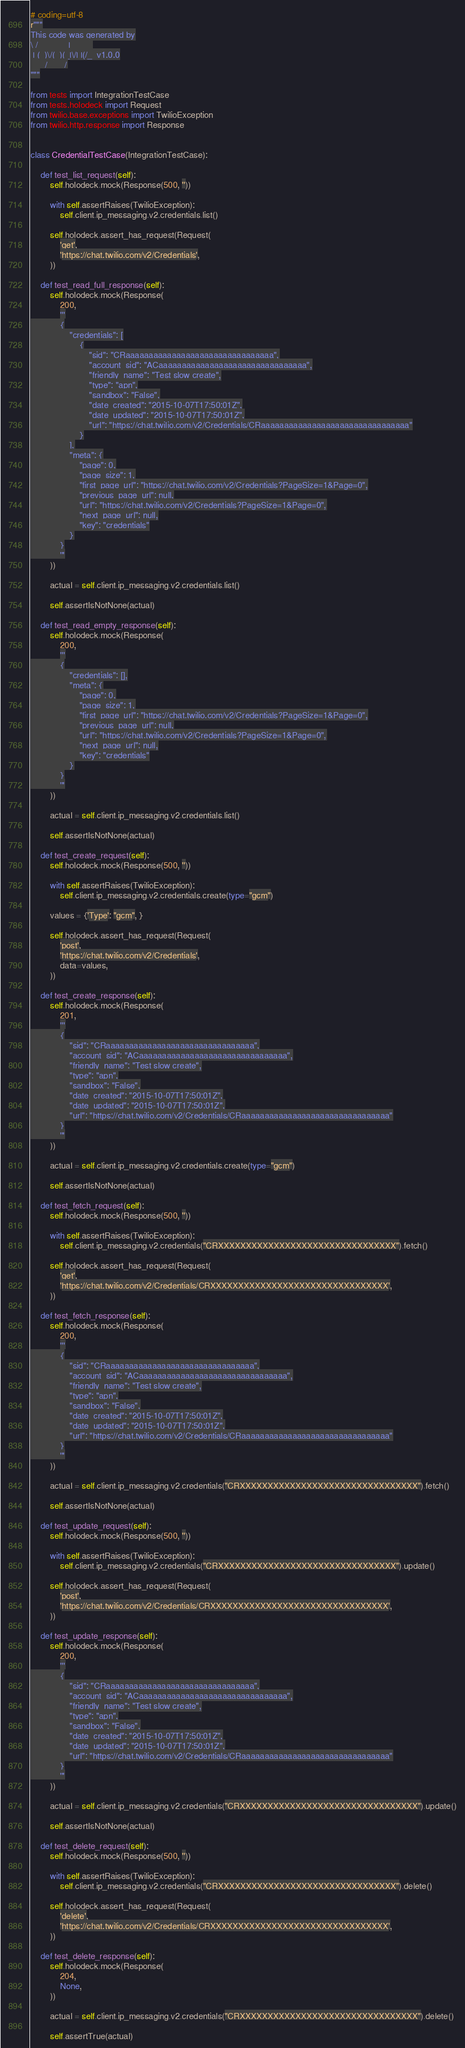Convert code to text. <code><loc_0><loc_0><loc_500><loc_500><_Python_># coding=utf-8
r"""
This code was generated by
\ / _    _  _|   _  _
 | (_)\/(_)(_|\/| |(/_  v1.0.0
      /       /
"""

from tests import IntegrationTestCase
from tests.holodeck import Request
from twilio.base.exceptions import TwilioException
from twilio.http.response import Response


class CredentialTestCase(IntegrationTestCase):

    def test_list_request(self):
        self.holodeck.mock(Response(500, ''))

        with self.assertRaises(TwilioException):
            self.client.ip_messaging.v2.credentials.list()

        self.holodeck.assert_has_request(Request(
            'get',
            'https://chat.twilio.com/v2/Credentials',
        ))

    def test_read_full_response(self):
        self.holodeck.mock(Response(
            200,
            '''
            {
                "credentials": [
                    {
                        "sid": "CRaaaaaaaaaaaaaaaaaaaaaaaaaaaaaaaa",
                        "account_sid": "ACaaaaaaaaaaaaaaaaaaaaaaaaaaaaaaaa",
                        "friendly_name": "Test slow create",
                        "type": "apn",
                        "sandbox": "False",
                        "date_created": "2015-10-07T17:50:01Z",
                        "date_updated": "2015-10-07T17:50:01Z",
                        "url": "https://chat.twilio.com/v2/Credentials/CRaaaaaaaaaaaaaaaaaaaaaaaaaaaaaaaa"
                    }
                ],
                "meta": {
                    "page": 0,
                    "page_size": 1,
                    "first_page_url": "https://chat.twilio.com/v2/Credentials?PageSize=1&Page=0",
                    "previous_page_url": null,
                    "url": "https://chat.twilio.com/v2/Credentials?PageSize=1&Page=0",
                    "next_page_url": null,
                    "key": "credentials"
                }
            }
            '''
        ))

        actual = self.client.ip_messaging.v2.credentials.list()

        self.assertIsNotNone(actual)

    def test_read_empty_response(self):
        self.holodeck.mock(Response(
            200,
            '''
            {
                "credentials": [],
                "meta": {
                    "page": 0,
                    "page_size": 1,
                    "first_page_url": "https://chat.twilio.com/v2/Credentials?PageSize=1&Page=0",
                    "previous_page_url": null,
                    "url": "https://chat.twilio.com/v2/Credentials?PageSize=1&Page=0",
                    "next_page_url": null,
                    "key": "credentials"
                }
            }
            '''
        ))

        actual = self.client.ip_messaging.v2.credentials.list()

        self.assertIsNotNone(actual)

    def test_create_request(self):
        self.holodeck.mock(Response(500, ''))

        with self.assertRaises(TwilioException):
            self.client.ip_messaging.v2.credentials.create(type="gcm")

        values = {'Type': "gcm", }

        self.holodeck.assert_has_request(Request(
            'post',
            'https://chat.twilio.com/v2/Credentials',
            data=values,
        ))

    def test_create_response(self):
        self.holodeck.mock(Response(
            201,
            '''
            {
                "sid": "CRaaaaaaaaaaaaaaaaaaaaaaaaaaaaaaaa",
                "account_sid": "ACaaaaaaaaaaaaaaaaaaaaaaaaaaaaaaaa",
                "friendly_name": "Test slow create",
                "type": "apn",
                "sandbox": "False",
                "date_created": "2015-10-07T17:50:01Z",
                "date_updated": "2015-10-07T17:50:01Z",
                "url": "https://chat.twilio.com/v2/Credentials/CRaaaaaaaaaaaaaaaaaaaaaaaaaaaaaaaa"
            }
            '''
        ))

        actual = self.client.ip_messaging.v2.credentials.create(type="gcm")

        self.assertIsNotNone(actual)

    def test_fetch_request(self):
        self.holodeck.mock(Response(500, ''))

        with self.assertRaises(TwilioException):
            self.client.ip_messaging.v2.credentials("CRXXXXXXXXXXXXXXXXXXXXXXXXXXXXXXXX").fetch()

        self.holodeck.assert_has_request(Request(
            'get',
            'https://chat.twilio.com/v2/Credentials/CRXXXXXXXXXXXXXXXXXXXXXXXXXXXXXXXX',
        ))

    def test_fetch_response(self):
        self.holodeck.mock(Response(
            200,
            '''
            {
                "sid": "CRaaaaaaaaaaaaaaaaaaaaaaaaaaaaaaaa",
                "account_sid": "ACaaaaaaaaaaaaaaaaaaaaaaaaaaaaaaaa",
                "friendly_name": "Test slow create",
                "type": "apn",
                "sandbox": "False",
                "date_created": "2015-10-07T17:50:01Z",
                "date_updated": "2015-10-07T17:50:01Z",
                "url": "https://chat.twilio.com/v2/Credentials/CRaaaaaaaaaaaaaaaaaaaaaaaaaaaaaaaa"
            }
            '''
        ))

        actual = self.client.ip_messaging.v2.credentials("CRXXXXXXXXXXXXXXXXXXXXXXXXXXXXXXXX").fetch()

        self.assertIsNotNone(actual)

    def test_update_request(self):
        self.holodeck.mock(Response(500, ''))

        with self.assertRaises(TwilioException):
            self.client.ip_messaging.v2.credentials("CRXXXXXXXXXXXXXXXXXXXXXXXXXXXXXXXX").update()

        self.holodeck.assert_has_request(Request(
            'post',
            'https://chat.twilio.com/v2/Credentials/CRXXXXXXXXXXXXXXXXXXXXXXXXXXXXXXXX',
        ))

    def test_update_response(self):
        self.holodeck.mock(Response(
            200,
            '''
            {
                "sid": "CRaaaaaaaaaaaaaaaaaaaaaaaaaaaaaaaa",
                "account_sid": "ACaaaaaaaaaaaaaaaaaaaaaaaaaaaaaaaa",
                "friendly_name": "Test slow create",
                "type": "apn",
                "sandbox": "False",
                "date_created": "2015-10-07T17:50:01Z",
                "date_updated": "2015-10-07T17:50:01Z",
                "url": "https://chat.twilio.com/v2/Credentials/CRaaaaaaaaaaaaaaaaaaaaaaaaaaaaaaaa"
            }
            '''
        ))

        actual = self.client.ip_messaging.v2.credentials("CRXXXXXXXXXXXXXXXXXXXXXXXXXXXXXXXX").update()

        self.assertIsNotNone(actual)

    def test_delete_request(self):
        self.holodeck.mock(Response(500, ''))

        with self.assertRaises(TwilioException):
            self.client.ip_messaging.v2.credentials("CRXXXXXXXXXXXXXXXXXXXXXXXXXXXXXXXX").delete()

        self.holodeck.assert_has_request(Request(
            'delete',
            'https://chat.twilio.com/v2/Credentials/CRXXXXXXXXXXXXXXXXXXXXXXXXXXXXXXXX',
        ))

    def test_delete_response(self):
        self.holodeck.mock(Response(
            204,
            None,
        ))

        actual = self.client.ip_messaging.v2.credentials("CRXXXXXXXXXXXXXXXXXXXXXXXXXXXXXXXX").delete()

        self.assertTrue(actual)
</code> 